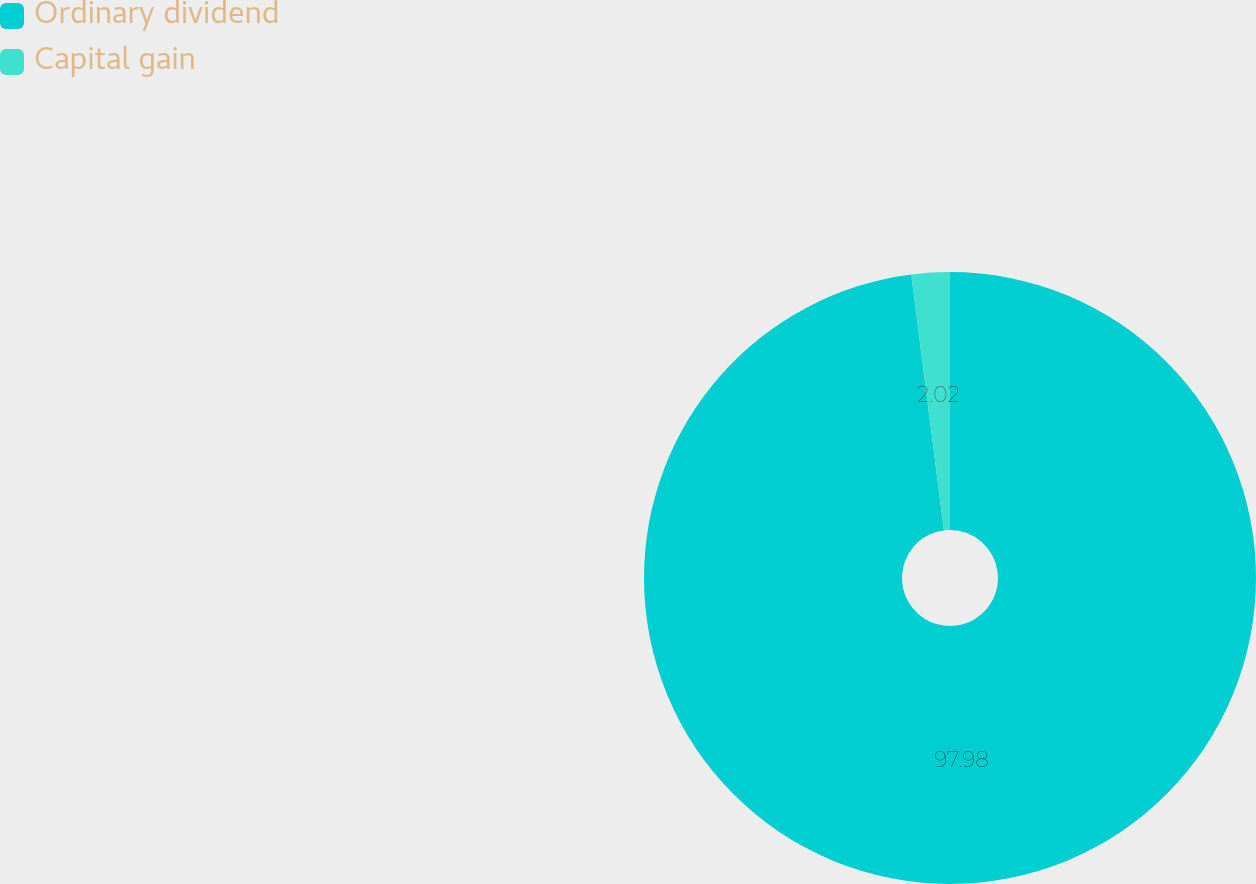Convert chart. <chart><loc_0><loc_0><loc_500><loc_500><pie_chart><fcel>Ordinary dividend<fcel>Capital gain<nl><fcel>97.98%<fcel>2.02%<nl></chart> 